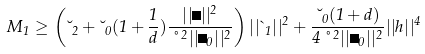Convert formula to latex. <formula><loc_0><loc_0><loc_500><loc_500>M _ { 1 } \geq \left ( \lambda _ { 2 } + \lambda _ { 0 } ( 1 + \frac { 1 } { d } ) { \frac { | | \psi | | ^ { 2 } } { \nu ^ { 2 } | | \psi _ { 0 } | | ^ { 2 } } } \right ) | | \theta _ { 1 } | | ^ { 2 } + { \frac { \lambda _ { 0 } ( 1 + d ) } { 4 \nu ^ { 2 } | | \psi _ { 0 } | | ^ { 2 } } } | | h | | ^ { 4 }</formula> 